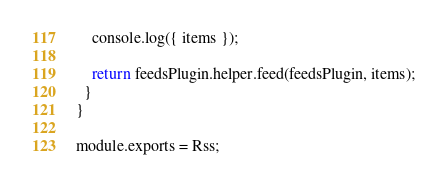<code> <loc_0><loc_0><loc_500><loc_500><_JavaScript_>
    console.log({ items });

    return feedsPlugin.helper.feed(feedsPlugin, items);
  }
}

module.exports = Rss;
</code> 